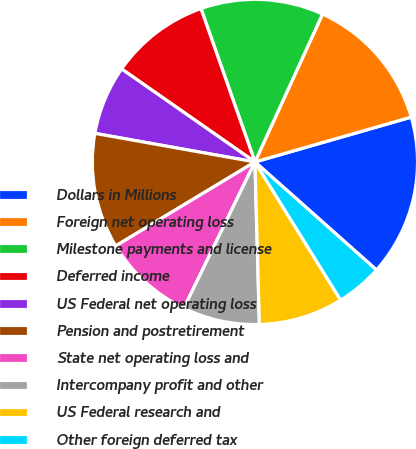<chart> <loc_0><loc_0><loc_500><loc_500><pie_chart><fcel>Dollars in Millions<fcel>Foreign net operating loss<fcel>Milestone payments and license<fcel>Deferred income<fcel>US Federal net operating loss<fcel>Pension and postretirement<fcel>State net operating loss and<fcel>Intercompany profit and other<fcel>US Federal research and<fcel>Other foreign deferred tax<nl><fcel>16.01%<fcel>13.73%<fcel>12.21%<fcel>9.92%<fcel>6.88%<fcel>11.45%<fcel>9.16%<fcel>7.64%<fcel>8.4%<fcel>4.6%<nl></chart> 